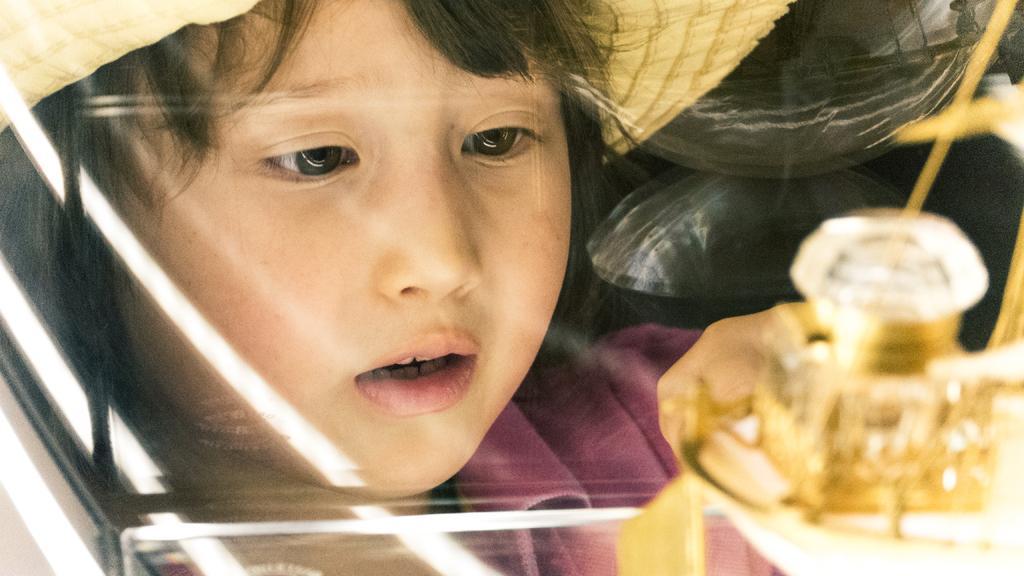Please provide a concise description of this image. In this picture we can see a girl wore a hat and in front of her we can see a glass object. 